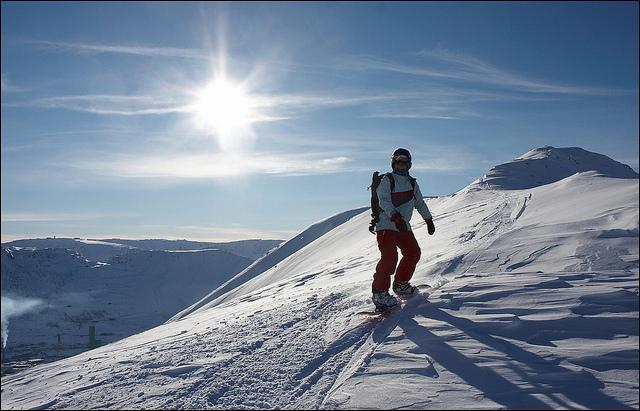Which direction will this person most likely go next?

Choices:
A) down slop
B) skyward
C) same elevation
D) higher down slop 